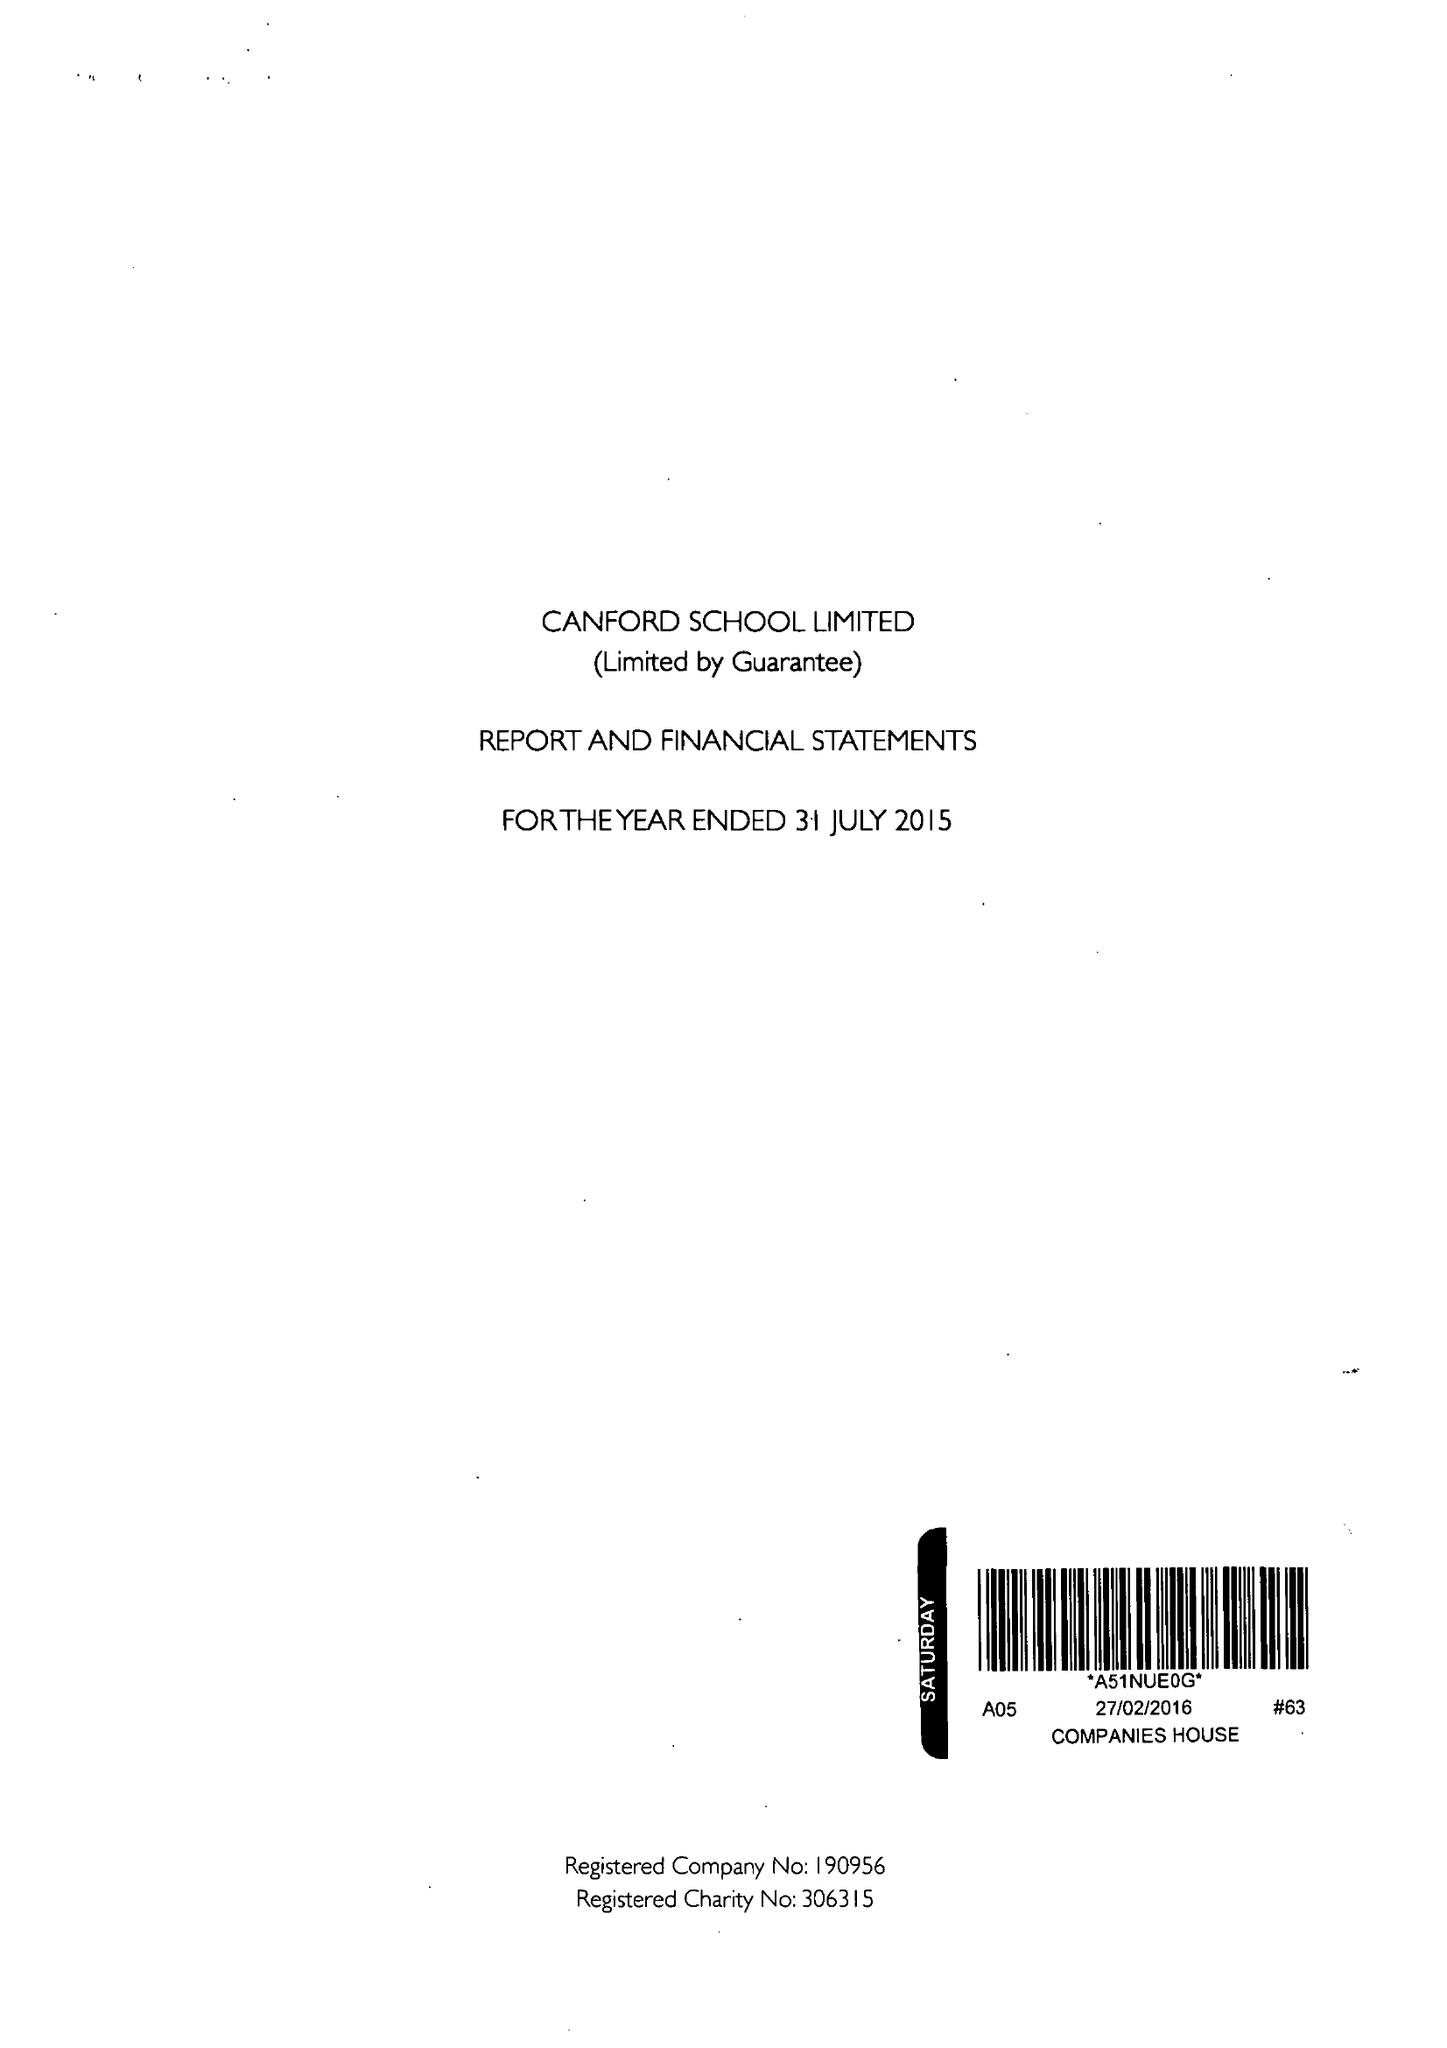What is the value for the charity_name?
Answer the question using a single word or phrase. Canford School Ltd. 